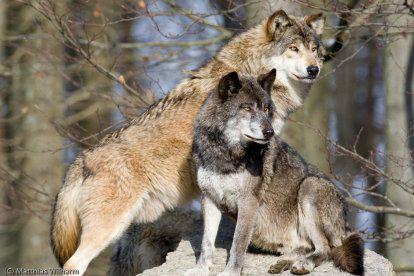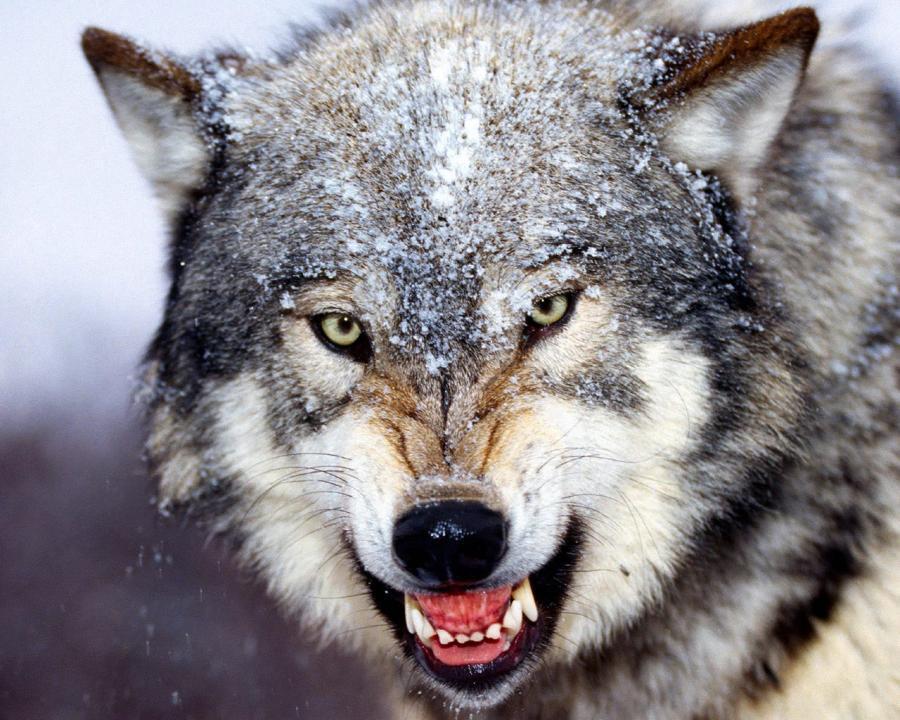The first image is the image on the left, the second image is the image on the right. Given the left and right images, does the statement "Multiple wolves are depicted in the left image." hold true? Answer yes or no. Yes. 